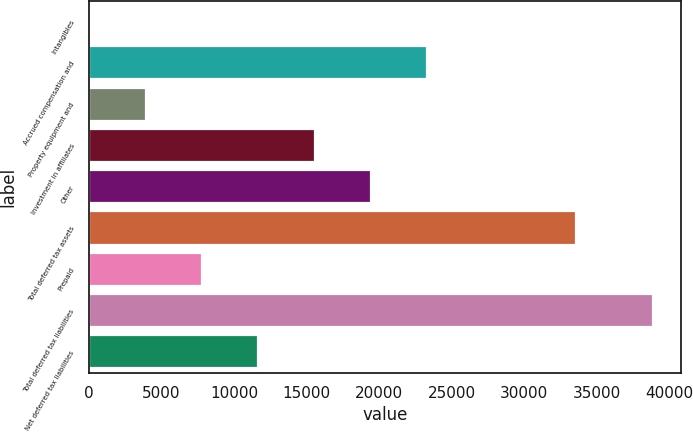Convert chart to OTSL. <chart><loc_0><loc_0><loc_500><loc_500><bar_chart><fcel>Intangibles<fcel>Accrued compensation and<fcel>Property equipment and<fcel>Investment in affiliates<fcel>Other<fcel>Total deferred tax assets<fcel>Prepaid<fcel>Total deferred tax liabilities<fcel>Net deferred tax liabilities<nl><fcel>38<fcel>23339<fcel>3921.5<fcel>15572<fcel>19455.5<fcel>33564<fcel>7805<fcel>38873<fcel>11688.5<nl></chart> 